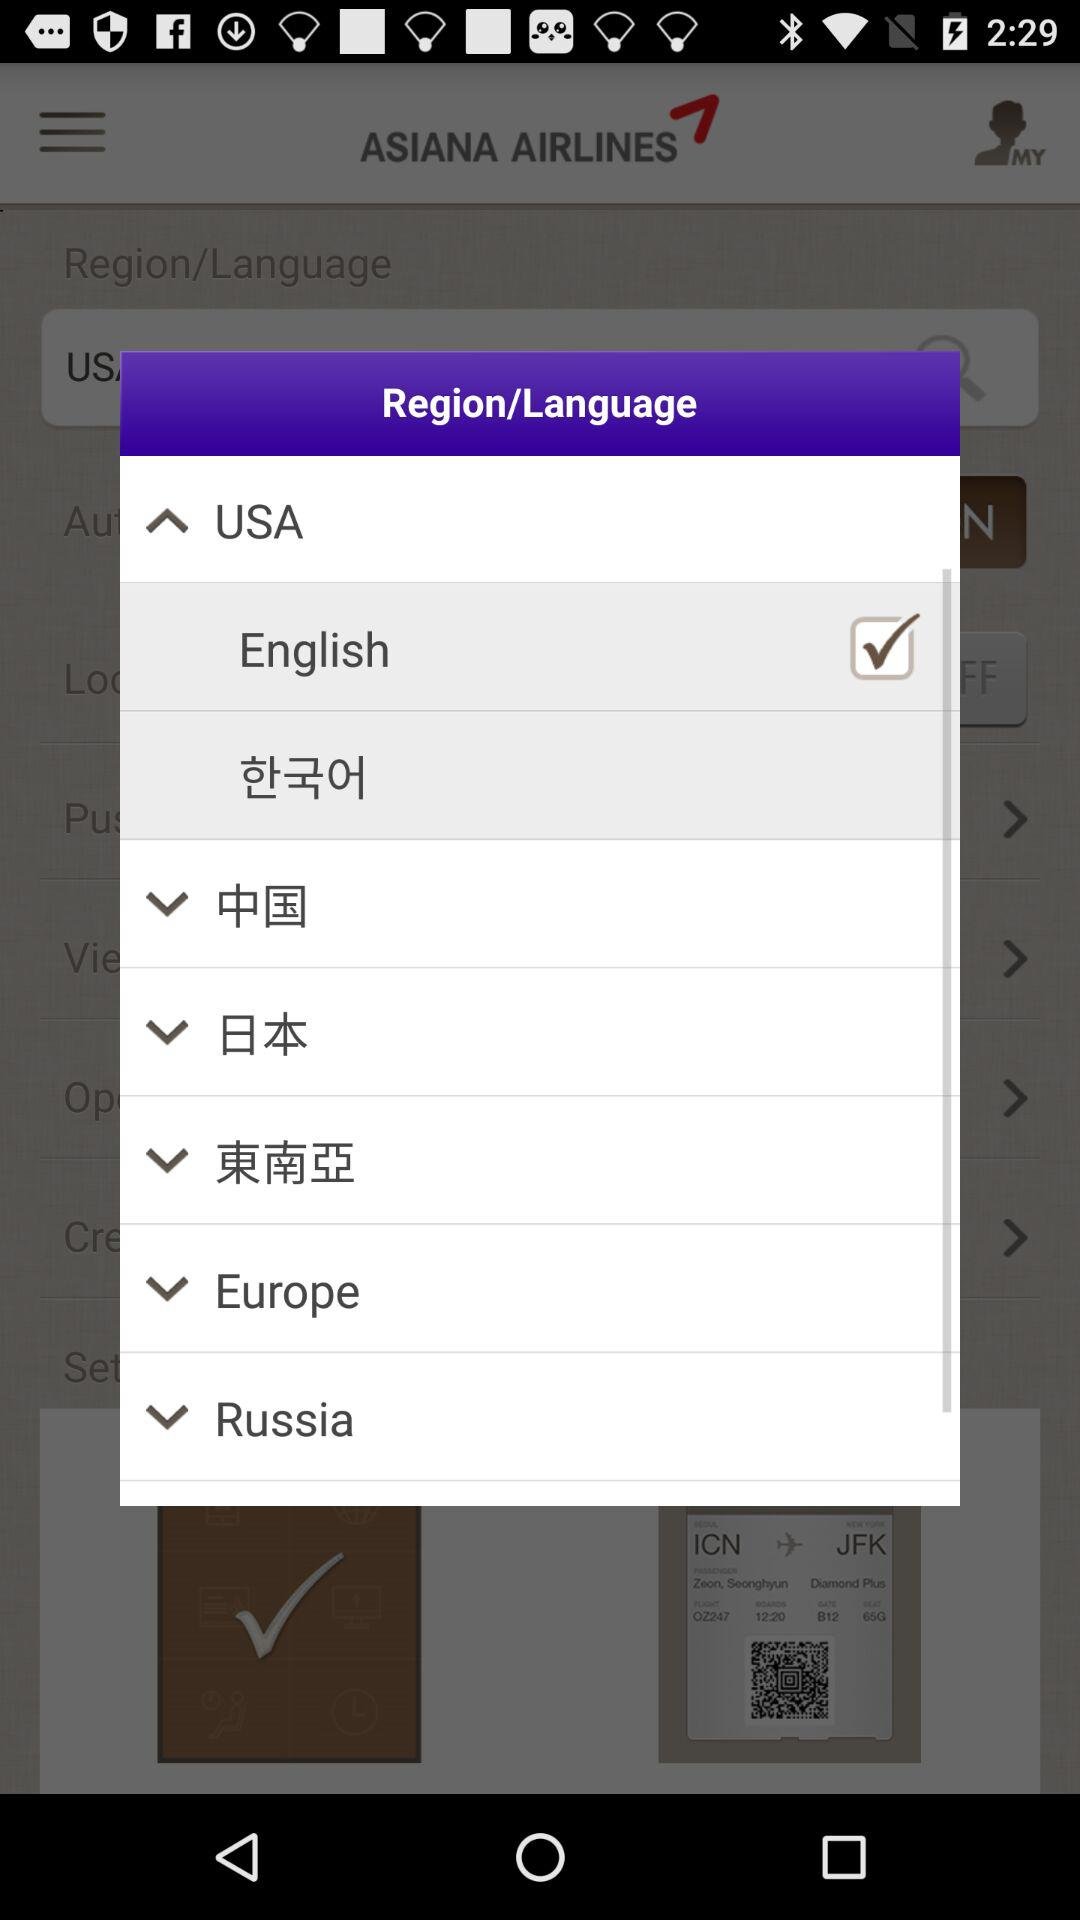Which language is selected? The selected language is English. 